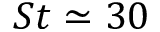Convert formula to latex. <formula><loc_0><loc_0><loc_500><loc_500>S t \simeq 3 0</formula> 